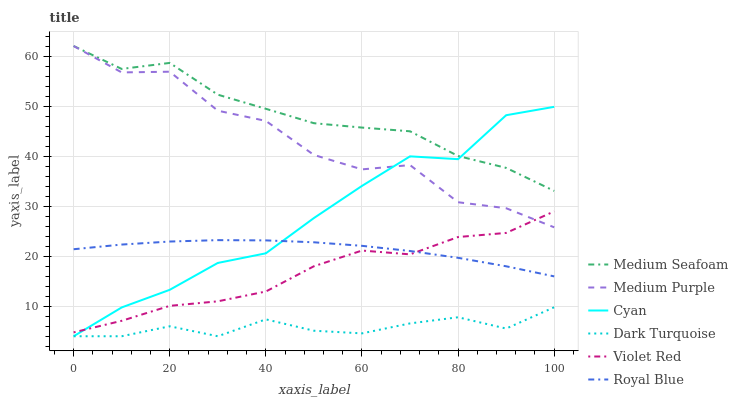Does Dark Turquoise have the minimum area under the curve?
Answer yes or no. Yes. Does Medium Purple have the minimum area under the curve?
Answer yes or no. No. Does Medium Purple have the maximum area under the curve?
Answer yes or no. No. Is Dark Turquoise the smoothest?
Answer yes or no. No. Is Dark Turquoise the roughest?
Answer yes or no. No. Does Medium Purple have the lowest value?
Answer yes or no. No. Does Dark Turquoise have the highest value?
Answer yes or no. No. Is Royal Blue less than Medium Purple?
Answer yes or no. Yes. Is Medium Seafoam greater than Royal Blue?
Answer yes or no. Yes. Does Royal Blue intersect Medium Purple?
Answer yes or no. No. 